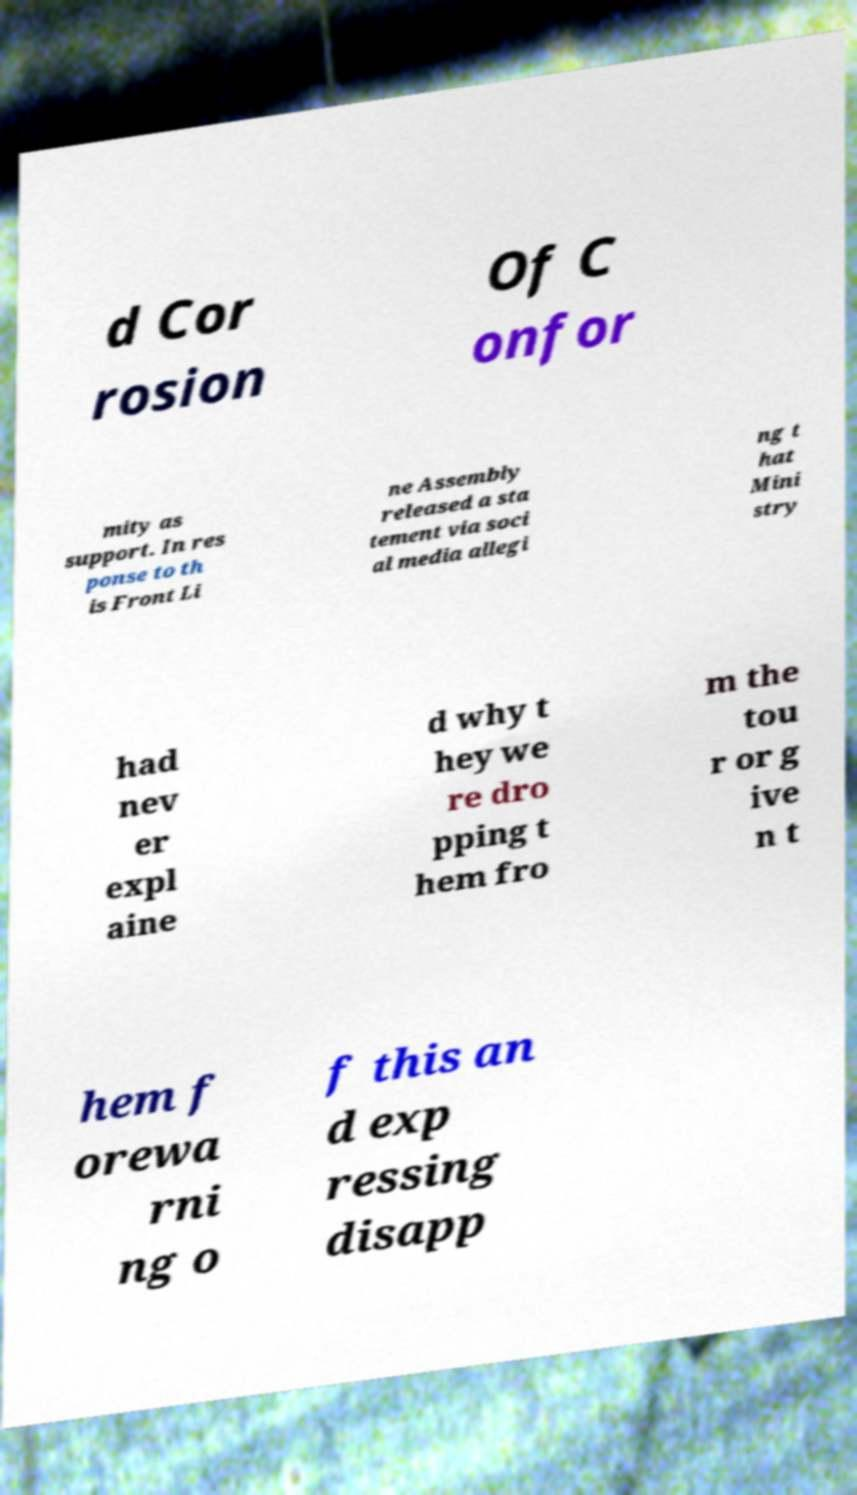Please read and relay the text visible in this image. What does it say? d Cor rosion Of C onfor mity as support. In res ponse to th is Front Li ne Assembly released a sta tement via soci al media allegi ng t hat Mini stry had nev er expl aine d why t hey we re dro pping t hem fro m the tou r or g ive n t hem f orewa rni ng o f this an d exp ressing disapp 